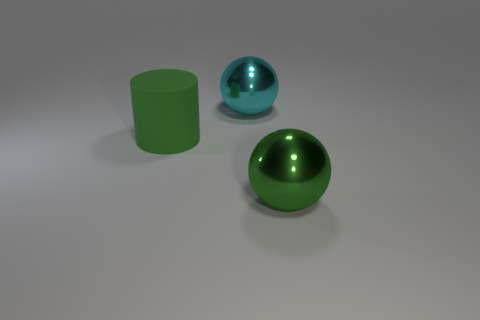Add 2 big green spheres. How many objects exist? 5 Subtract all green balls. How many balls are left? 1 Add 2 gray metal objects. How many gray metal objects exist? 2 Subtract 0 gray cylinders. How many objects are left? 3 Subtract all cylinders. How many objects are left? 2 Subtract 1 cylinders. How many cylinders are left? 0 Subtract all brown balls. Subtract all yellow cylinders. How many balls are left? 2 Subtract all red cubes. How many red cylinders are left? 0 Subtract all large gray cubes. Subtract all big spheres. How many objects are left? 1 Add 1 large shiny objects. How many large shiny objects are left? 3 